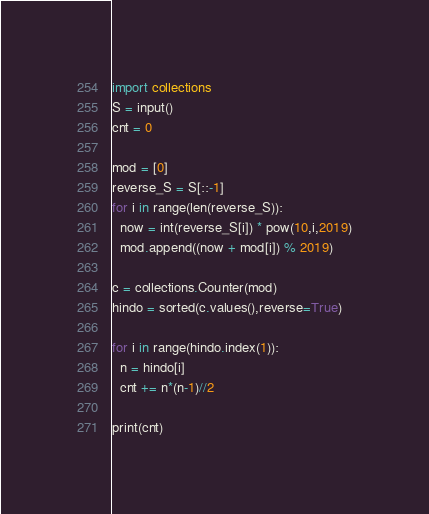<code> <loc_0><loc_0><loc_500><loc_500><_Python_>import collections
S = input()
cnt = 0

mod = [0]
reverse_S = S[::-1]
for i in range(len(reverse_S)):
  now = int(reverse_S[i]) * pow(10,i,2019)
  mod.append((now + mod[i]) % 2019)

c = collections.Counter(mod)
hindo = sorted(c.values(),reverse=True)

for i in range(hindo.index(1)):
  n = hindo[i]
  cnt += n*(n-1)//2

print(cnt)</code> 